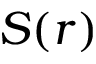<formula> <loc_0><loc_0><loc_500><loc_500>S ( r )</formula> 